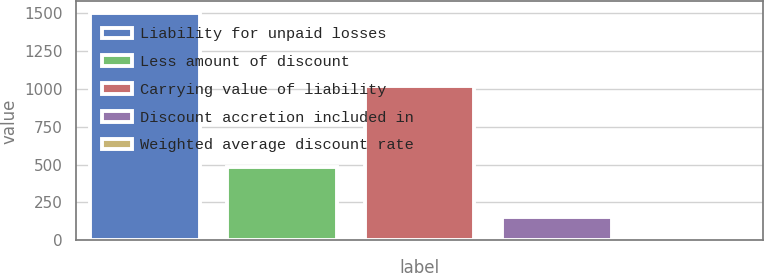Convert chart. <chart><loc_0><loc_0><loc_500><loc_500><bar_chart><fcel>Liability for unpaid losses<fcel>Less amount of discount<fcel>Carrying value of liability<fcel>Discount accretion included in<fcel>Weighted average discount rate<nl><fcel>1504<fcel>483<fcel>1021<fcel>153.2<fcel>3.11<nl></chart> 